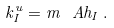<formula> <loc_0><loc_0><loc_500><loc_500>k _ { I } ^ { u } = m ^ { \ } A h _ { I } \, .</formula> 